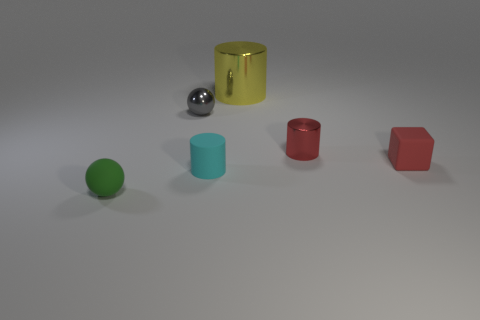Subtract all metallic cylinders. How many cylinders are left? 1 Subtract all cubes. How many objects are left? 5 Add 3 balls. How many objects exist? 9 Subtract all large gray balls. Subtract all yellow things. How many objects are left? 5 Add 2 big things. How many big things are left? 3 Add 2 cyan matte cylinders. How many cyan matte cylinders exist? 3 Subtract 0 gray cylinders. How many objects are left? 6 Subtract all gray cylinders. Subtract all brown spheres. How many cylinders are left? 3 